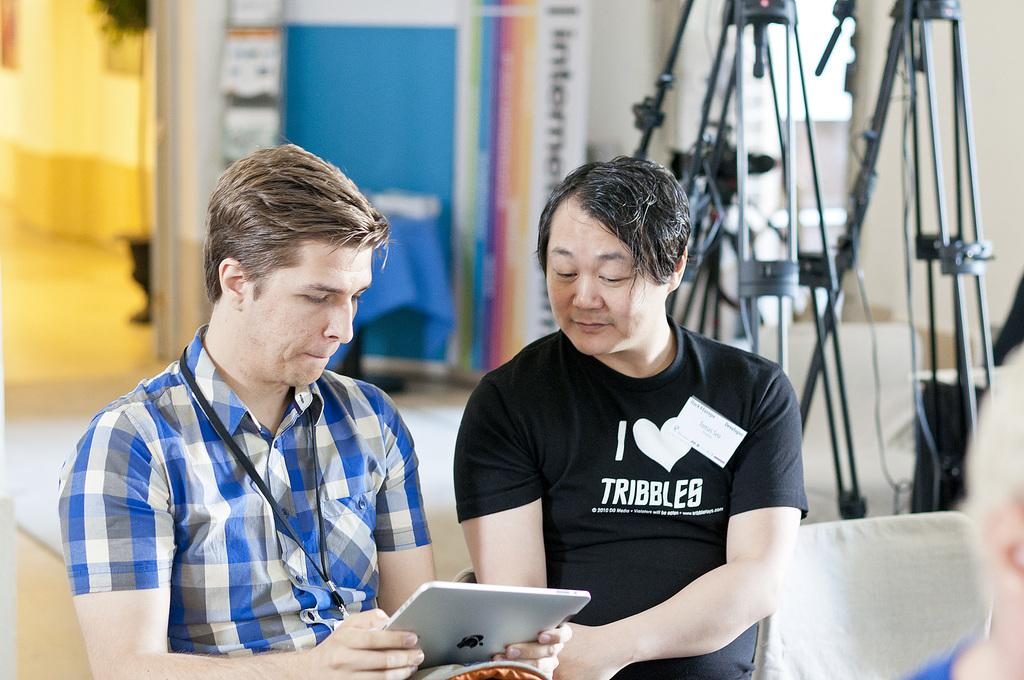How many people are in the image? There are two men in the image. What is one of the men holding? One of the men is holding an Apple device. What type of furniture can be seen in the image? There are stands and a chair in the image. What part of the room is visible in the image? The floor is visible in the image. What is in the background of the image? A: There is a wall in the background of the image. Where is the sofa located in the image? There is no sofa present in the image. What type of hook can be seen on the wall in the image? There are no hooks visible on the wall in the image. 